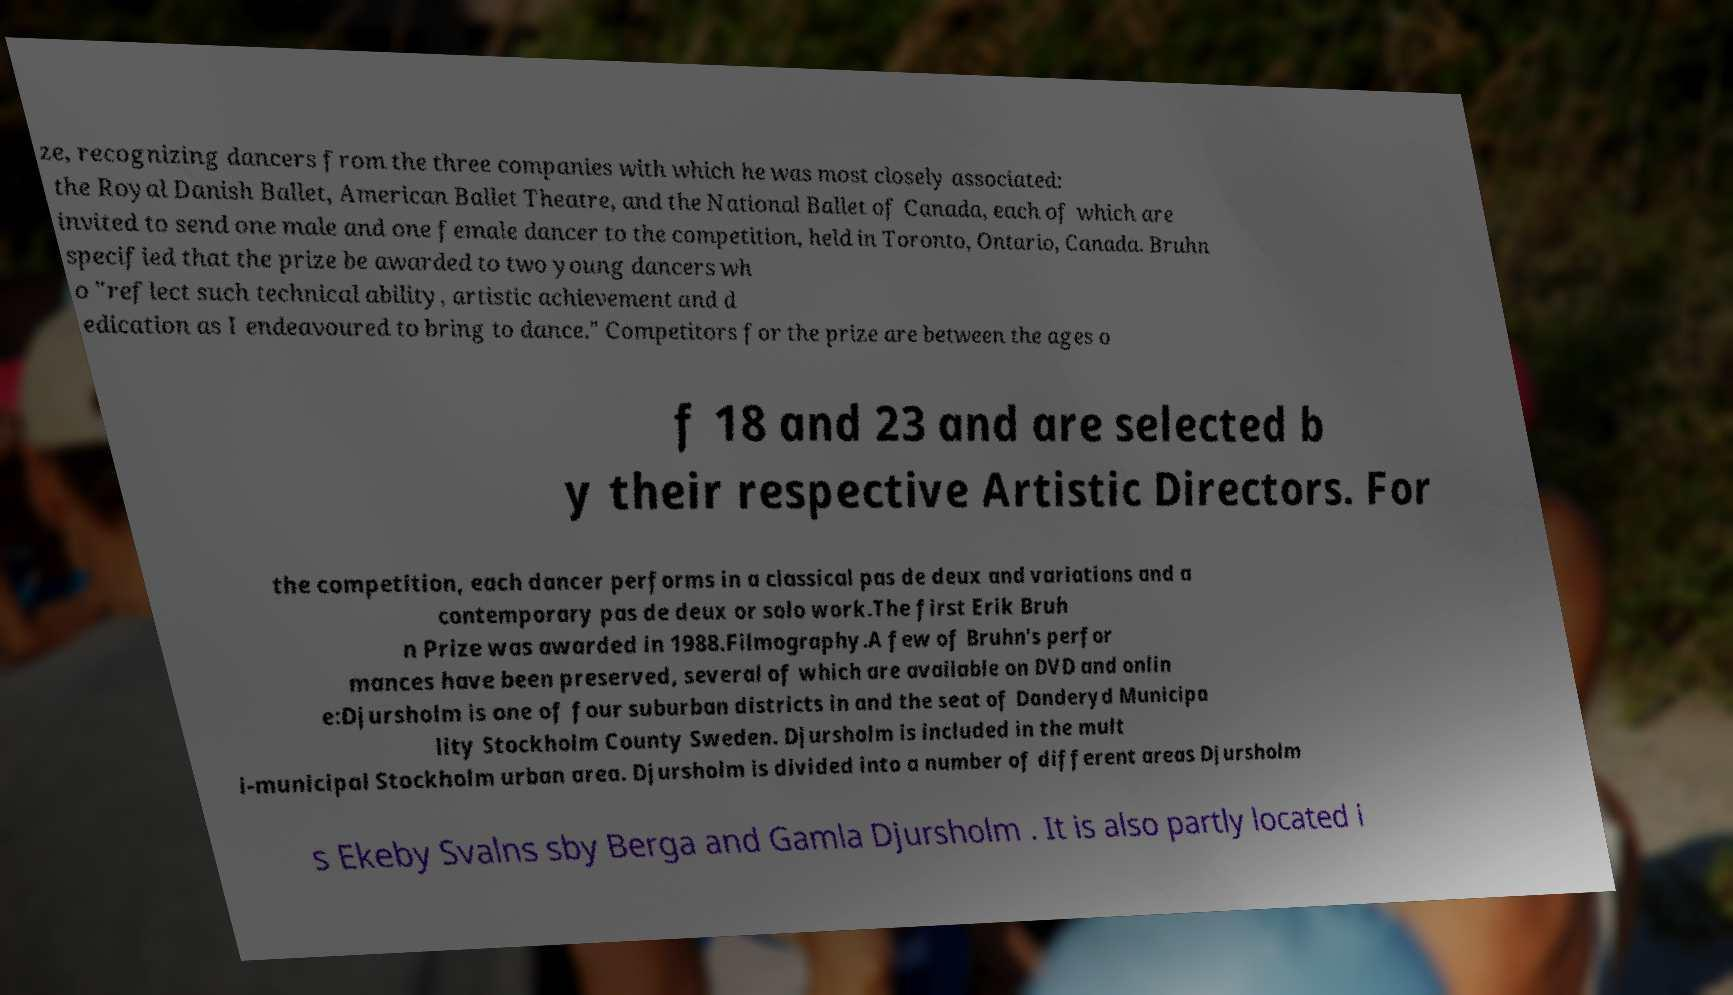For documentation purposes, I need the text within this image transcribed. Could you provide that? ze, recognizing dancers from the three companies with which he was most closely associated: the Royal Danish Ballet, American Ballet Theatre, and the National Ballet of Canada, each of which are invited to send one male and one female dancer to the competition, held in Toronto, Ontario, Canada. Bruhn specified that the prize be awarded to two young dancers wh o "reflect such technical ability, artistic achievement and d edication as I endeavoured to bring to dance." Competitors for the prize are between the ages o f 18 and 23 and are selected b y their respective Artistic Directors. For the competition, each dancer performs in a classical pas de deux and variations and a contemporary pas de deux or solo work.The first Erik Bruh n Prize was awarded in 1988.Filmography.A few of Bruhn's perfor mances have been preserved, several of which are available on DVD and onlin e:Djursholm is one of four suburban districts in and the seat of Danderyd Municipa lity Stockholm County Sweden. Djursholm is included in the mult i-municipal Stockholm urban area. Djursholm is divided into a number of different areas Djursholm s Ekeby Svalns sby Berga and Gamla Djursholm . It is also partly located i 